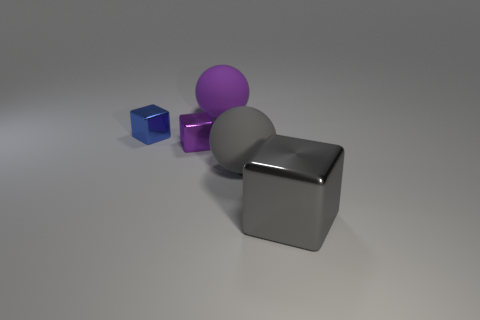Is there any other thing that is the same material as the small purple block?
Your response must be concise. Yes. There is a gray object that is in front of the big gray thing that is left of the shiny block on the right side of the gray sphere; what is its material?
Provide a short and direct response. Metal. There is a big object that is both to the left of the gray cube and right of the purple matte sphere; what material is it?
Provide a succinct answer. Rubber. What number of big gray objects are the same shape as the large purple matte thing?
Provide a short and direct response. 1. There is a gray metallic block that is in front of the large gray object left of the big gray block; how big is it?
Provide a succinct answer. Large. Do the large matte sphere behind the tiny blue object and the block in front of the big gray rubber ball have the same color?
Offer a very short reply. No. What number of gray objects are behind the gray object to the right of the gray object behind the big metallic block?
Provide a short and direct response. 1. What number of things are on the right side of the tiny purple metallic thing and on the left side of the big shiny thing?
Provide a succinct answer. 2. Is the number of purple balls in front of the small blue thing greater than the number of big gray cubes?
Your answer should be very brief. No. What number of purple metallic blocks are the same size as the blue metal cube?
Provide a short and direct response. 1. 